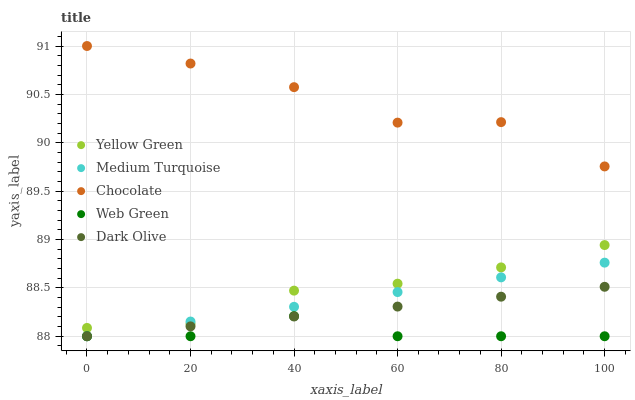Does Web Green have the minimum area under the curve?
Answer yes or no. Yes. Does Chocolate have the maximum area under the curve?
Answer yes or no. Yes. Does Yellow Green have the minimum area under the curve?
Answer yes or no. No. Does Yellow Green have the maximum area under the curve?
Answer yes or no. No. Is Medium Turquoise the smoothest?
Answer yes or no. Yes. Is Chocolate the roughest?
Answer yes or no. Yes. Is Web Green the smoothest?
Answer yes or no. No. Is Web Green the roughest?
Answer yes or no. No. Does Dark Olive have the lowest value?
Answer yes or no. Yes. Does Yellow Green have the lowest value?
Answer yes or no. No. Does Chocolate have the highest value?
Answer yes or no. Yes. Does Yellow Green have the highest value?
Answer yes or no. No. Is Dark Olive less than Yellow Green?
Answer yes or no. Yes. Is Chocolate greater than Yellow Green?
Answer yes or no. Yes. Does Yellow Green intersect Medium Turquoise?
Answer yes or no. Yes. Is Yellow Green less than Medium Turquoise?
Answer yes or no. No. Is Yellow Green greater than Medium Turquoise?
Answer yes or no. No. Does Dark Olive intersect Yellow Green?
Answer yes or no. No. 